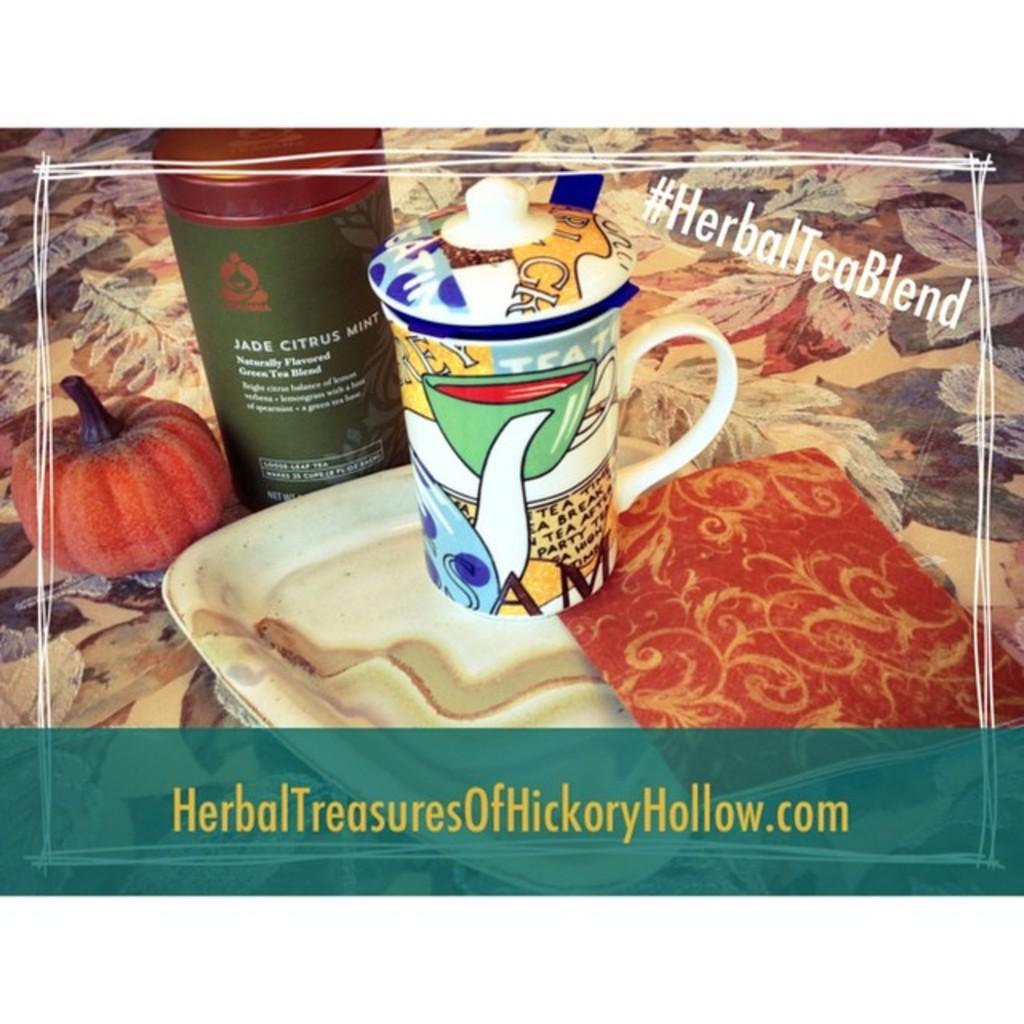In one or two sentences, can you explain what this image depicts? In this picture we can see the advertisement of an herbal product with its website printed at the bottom. Here we can see a small fruit, a tray, a mug and a bottle kept on a floral surface. 